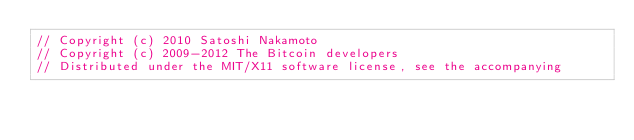<code> <loc_0><loc_0><loc_500><loc_500><_C++_>// Copyright (c) 2010 Satoshi Nakamoto
// Copyright (c) 2009-2012 The Bitcoin developers
// Distributed under the MIT/X11 software license, see the accompanying</code> 